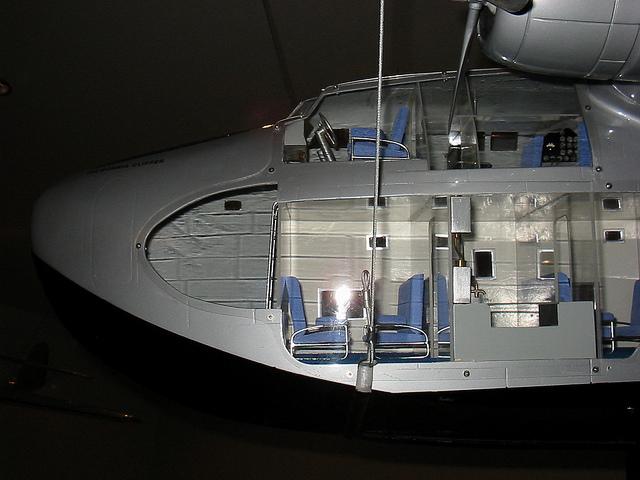Is this plane ready to fly?
Keep it brief. No. What is this a picture of?
Be succinct. Airplane. Is it day or night?
Write a very short answer. Night. How many boats are there?
Be succinct. 1. 